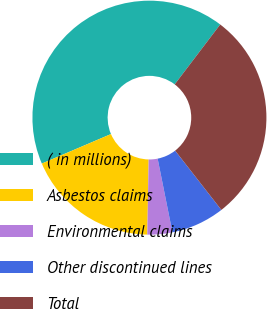Convert chart. <chart><loc_0><loc_0><loc_500><loc_500><pie_chart><fcel>( in millions)<fcel>Asbestos claims<fcel>Environmental claims<fcel>Other discontinued lines<fcel>Total<nl><fcel>41.76%<fcel>18.29%<fcel>3.44%<fcel>7.39%<fcel>29.12%<nl></chart> 